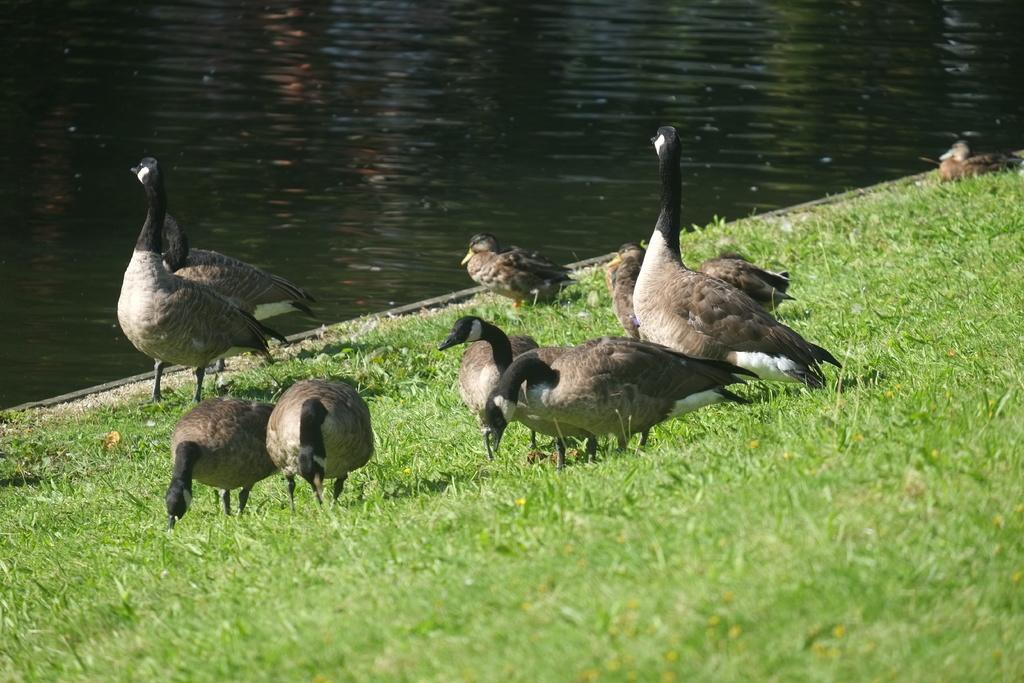Could you give a brief overview of what you see in this image? As we can see in the image there is grass, birds and water. 